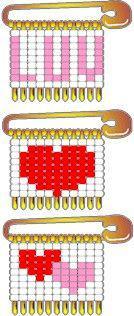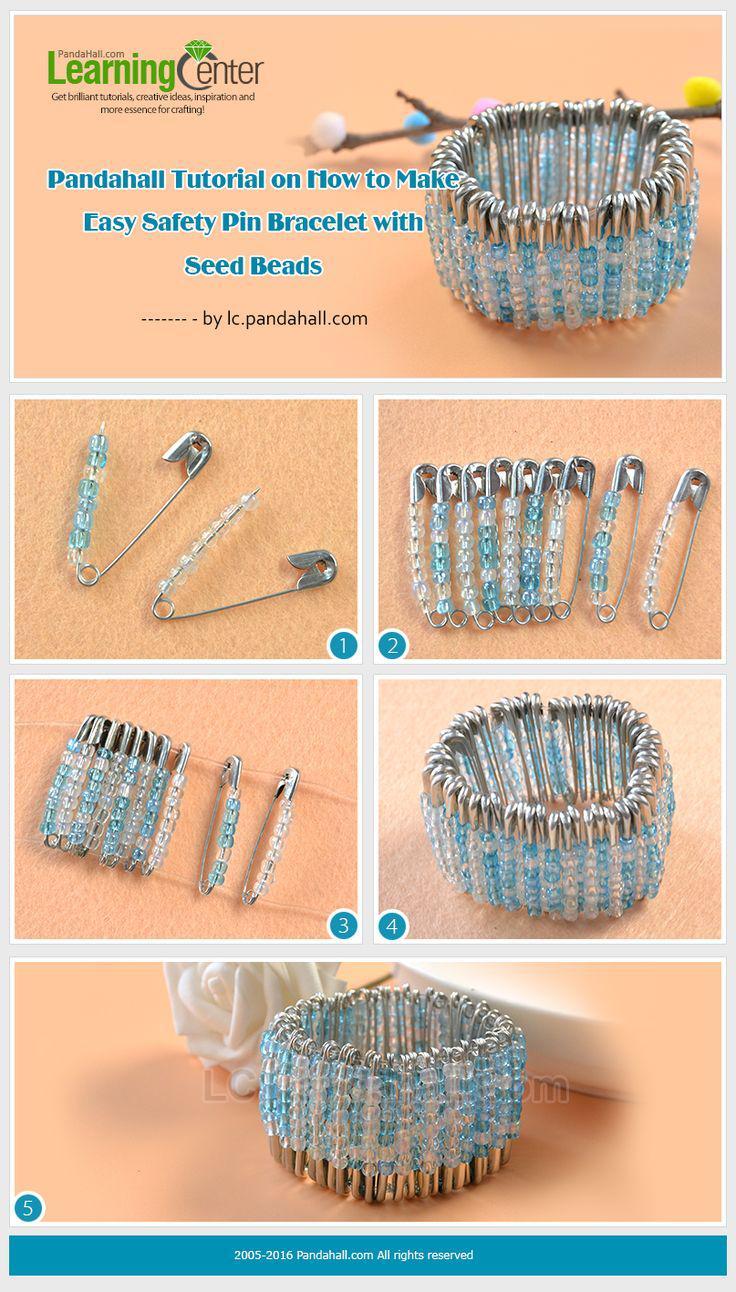The first image is the image on the left, the second image is the image on the right. Evaluate the accuracy of this statement regarding the images: "The pins in the image on the left show hearts.". Is it true? Answer yes or no. Yes. The first image is the image on the left, the second image is the image on the right. Evaluate the accuracy of this statement regarding the images: "Some safety pins are strung with beads that create heart shapes.". Is it true? Answer yes or no. Yes. 